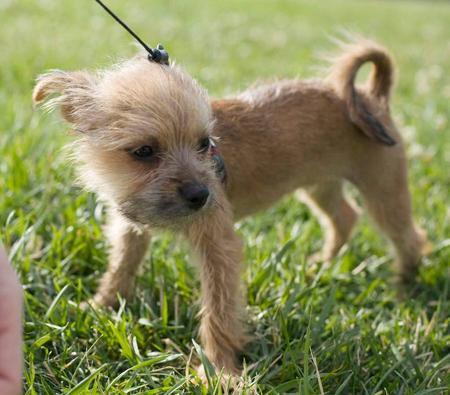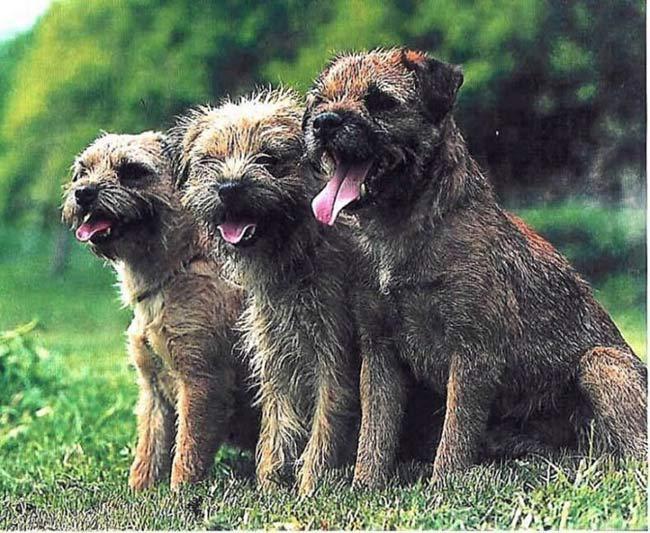The first image is the image on the left, the second image is the image on the right. For the images shown, is this caption "There is some green grass in the background of every image." true? Answer yes or no. Yes. The first image is the image on the left, the second image is the image on the right. Analyze the images presented: Is the assertion "The dog on the right has a blue collar" valid? Answer yes or no. No. 